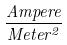Convert formula to latex. <formula><loc_0><loc_0><loc_500><loc_500>\frac { A m p e r e } { M e t e r ^ { 2 } }</formula> 